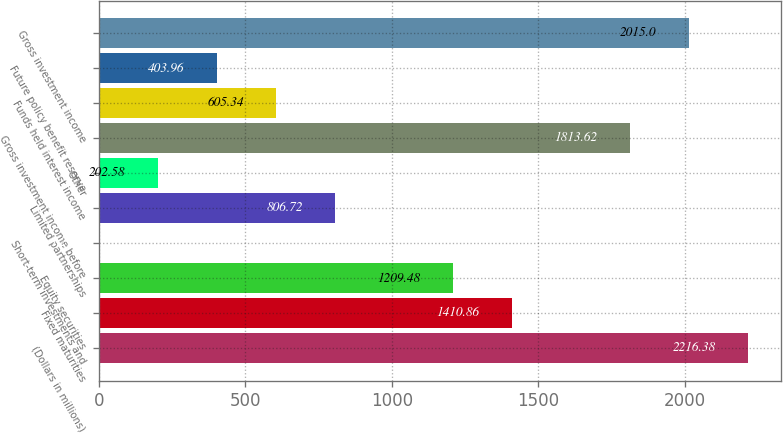Convert chart. <chart><loc_0><loc_0><loc_500><loc_500><bar_chart><fcel>(Dollars in millions)<fcel>Fixed maturities<fcel>Equity securities<fcel>Short-term investments and<fcel>Limited partnerships<fcel>Other<fcel>Gross investment income before<fcel>Funds held interest income<fcel>Future policy benefit reserve<fcel>Gross investment income<nl><fcel>2216.38<fcel>1410.86<fcel>1209.48<fcel>1.2<fcel>806.72<fcel>202.58<fcel>1813.62<fcel>605.34<fcel>403.96<fcel>2015<nl></chart> 